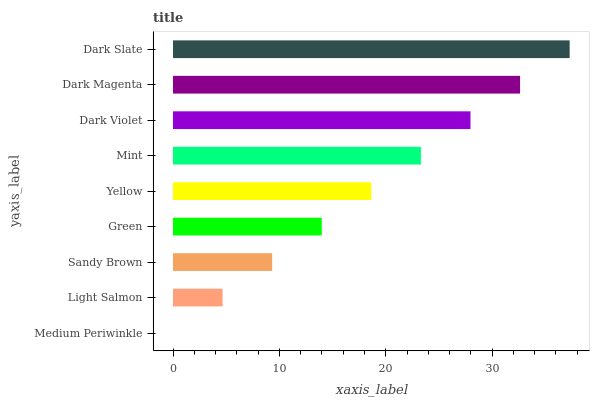Is Medium Periwinkle the minimum?
Answer yes or no. Yes. Is Dark Slate the maximum?
Answer yes or no. Yes. Is Light Salmon the minimum?
Answer yes or no. No. Is Light Salmon the maximum?
Answer yes or no. No. Is Light Salmon greater than Medium Periwinkle?
Answer yes or no. Yes. Is Medium Periwinkle less than Light Salmon?
Answer yes or no. Yes. Is Medium Periwinkle greater than Light Salmon?
Answer yes or no. No. Is Light Salmon less than Medium Periwinkle?
Answer yes or no. No. Is Yellow the high median?
Answer yes or no. Yes. Is Yellow the low median?
Answer yes or no. Yes. Is Sandy Brown the high median?
Answer yes or no. No. Is Dark Magenta the low median?
Answer yes or no. No. 